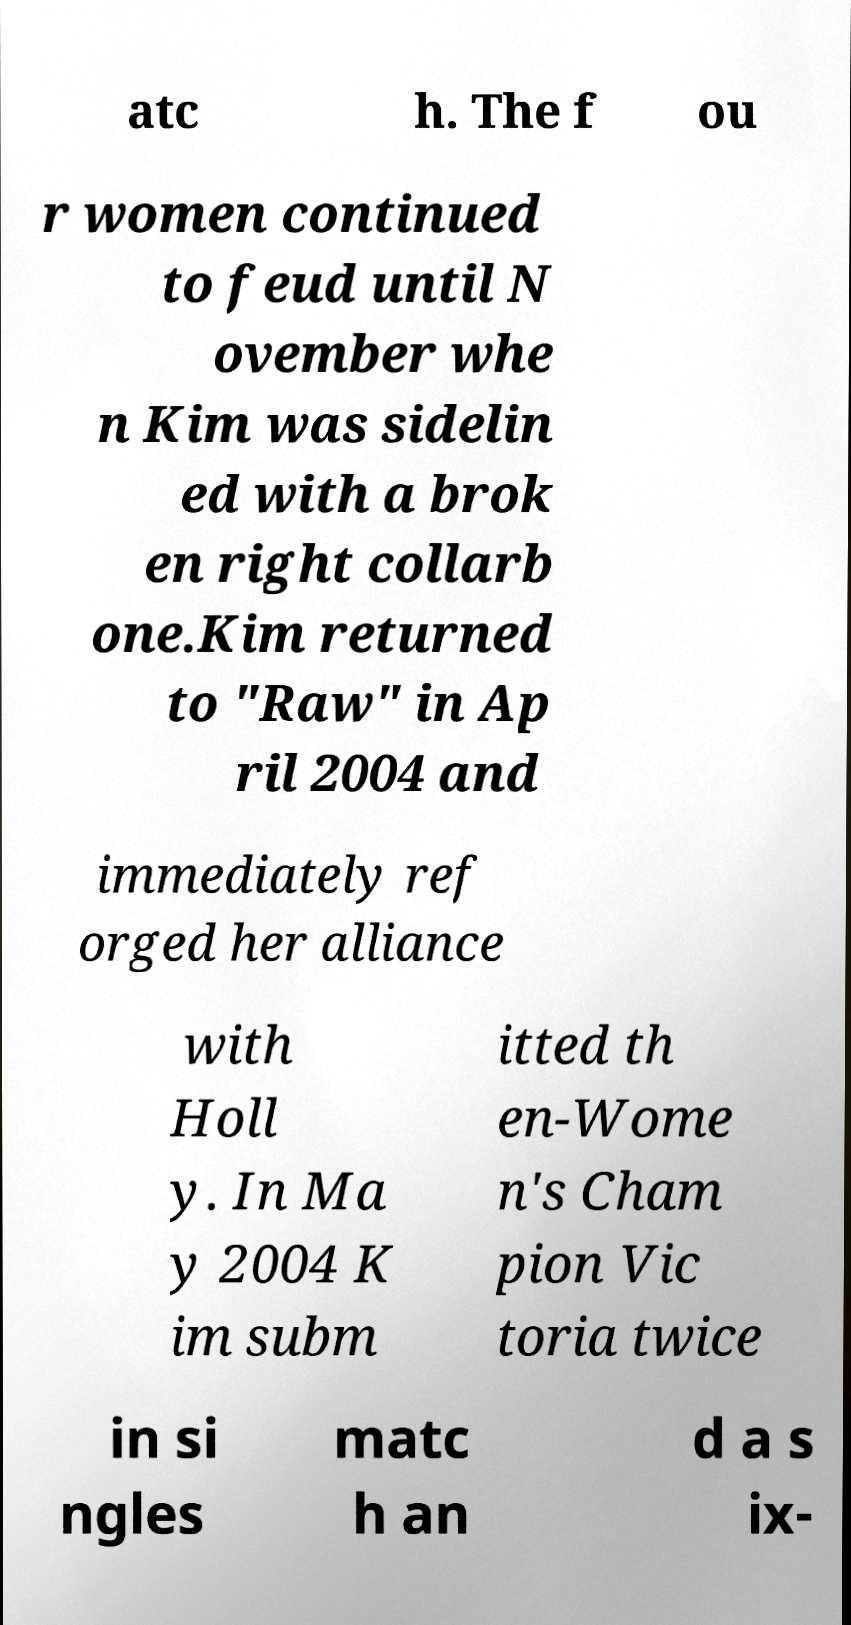There's text embedded in this image that I need extracted. Can you transcribe it verbatim? atc h. The f ou r women continued to feud until N ovember whe n Kim was sidelin ed with a brok en right collarb one.Kim returned to "Raw" in Ap ril 2004 and immediately ref orged her alliance with Holl y. In Ma y 2004 K im subm itted th en-Wome n's Cham pion Vic toria twice in si ngles matc h an d a s ix- 